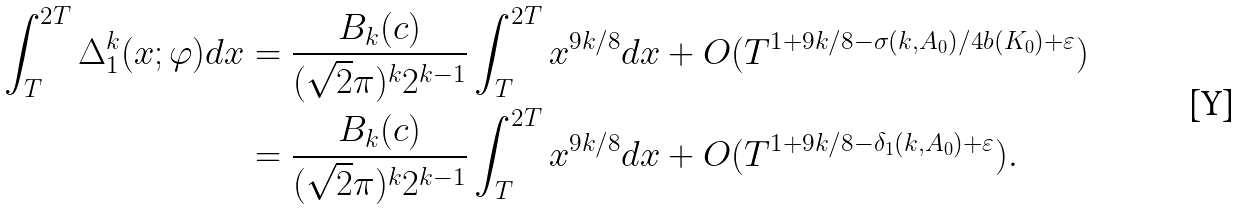<formula> <loc_0><loc_0><loc_500><loc_500>\int _ { T } ^ { 2 T } \Delta _ { 1 } ^ { k } ( x ; \varphi ) d x & = \frac { B _ { k } ( c ) } { ( \sqrt { 2 } \pi ) ^ { k } 2 ^ { k - 1 } } \int _ { T } ^ { 2 T } x ^ { 9 k / 8 } d x + O ( T ^ { 1 + 9 k / 8 - \sigma ( k , A _ { 0 } ) / 4 b ( K _ { 0 } ) + \varepsilon } ) \\ & = \frac { B _ { k } ( c ) } { ( \sqrt { 2 } \pi ) ^ { k } 2 ^ { k - 1 } } \int _ { T } ^ { 2 T } x ^ { 9 k / 8 } d x + O ( T ^ { 1 + 9 k / 8 - \delta _ { 1 } ( k , A _ { 0 } ) + \varepsilon } ) .</formula> 